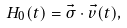Convert formula to latex. <formula><loc_0><loc_0><loc_500><loc_500>H _ { 0 } ( t ) = \vec { \sigma } \cdot \vec { v } ( t ) ,</formula> 